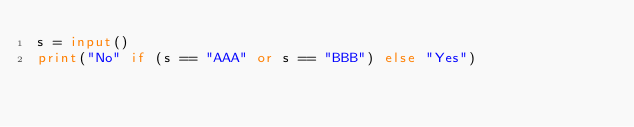Convert code to text. <code><loc_0><loc_0><loc_500><loc_500><_Python_>s = input()
print("No" if (s == "AAA" or s == "BBB") else "Yes")</code> 